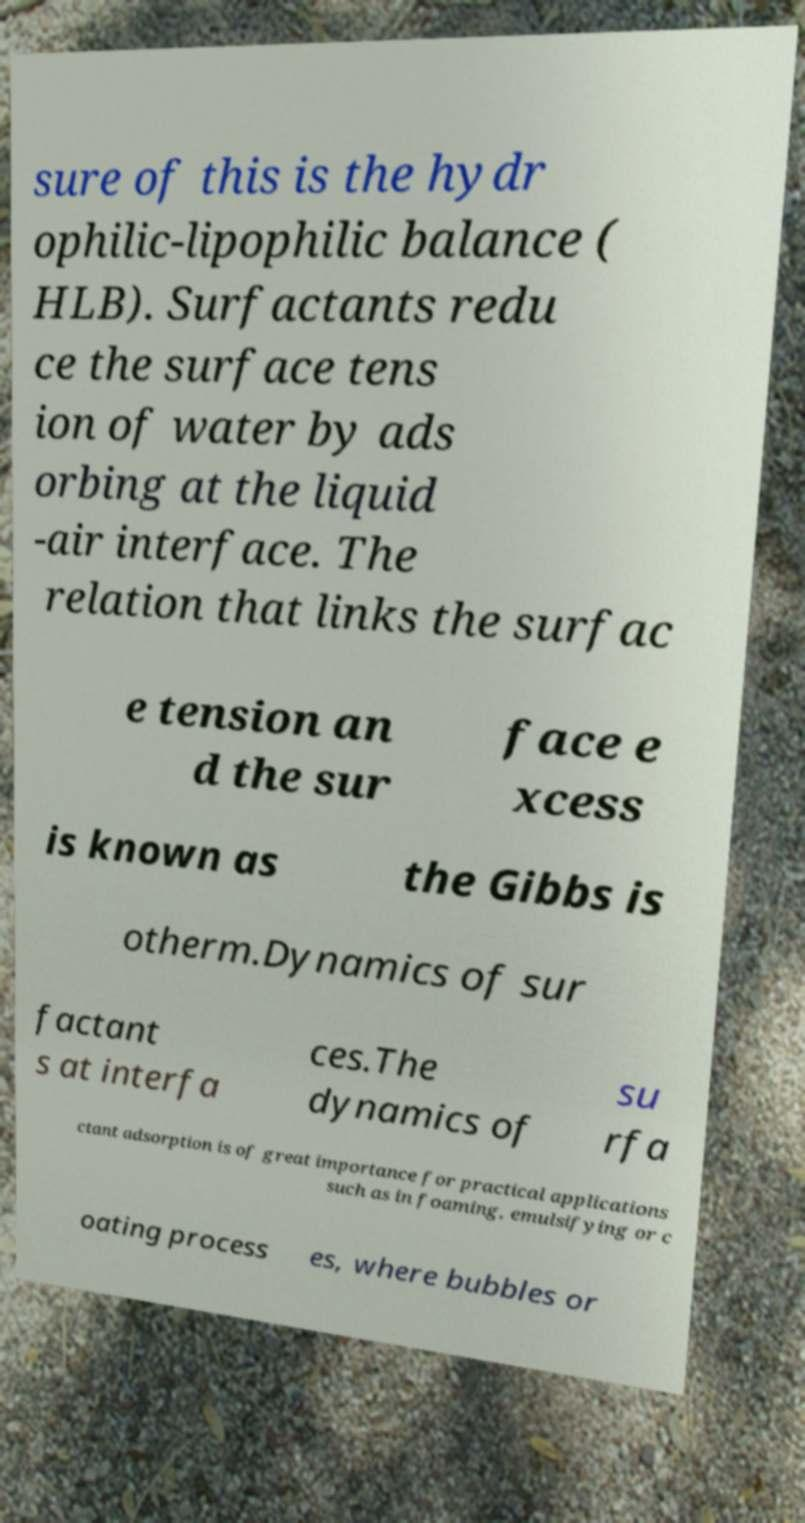I need the written content from this picture converted into text. Can you do that? sure of this is the hydr ophilic-lipophilic balance ( HLB). Surfactants redu ce the surface tens ion of water by ads orbing at the liquid -air interface. The relation that links the surfac e tension an d the sur face e xcess is known as the Gibbs is otherm.Dynamics of sur factant s at interfa ces.The dynamics of su rfa ctant adsorption is of great importance for practical applications such as in foaming, emulsifying or c oating process es, where bubbles or 